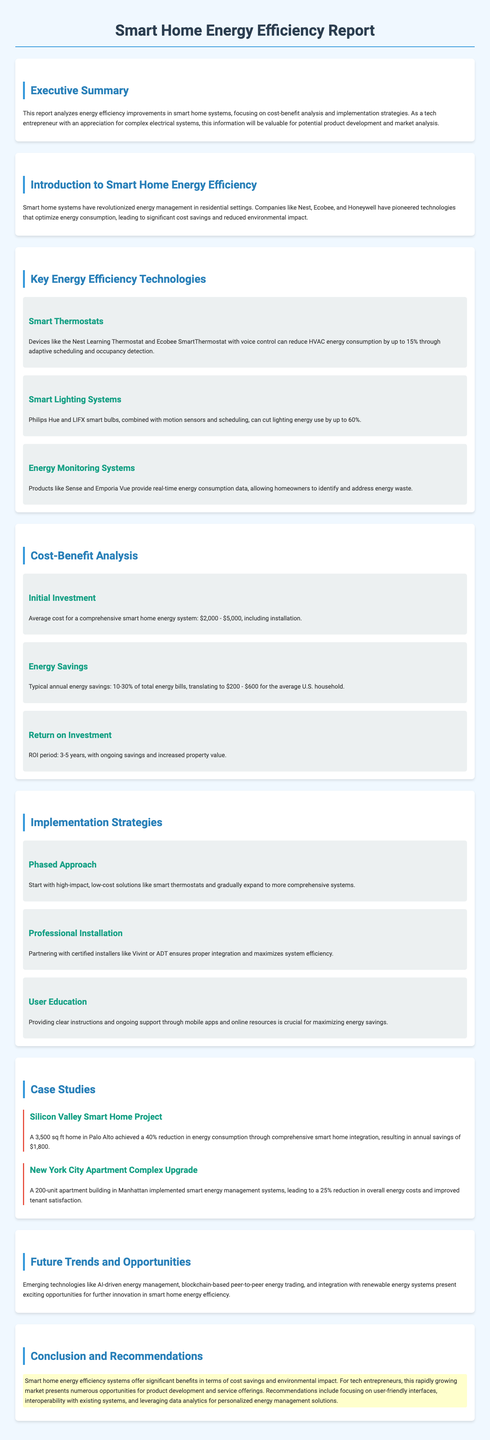What is the average cost for a comprehensive smart home energy system? The average cost is mentioned in the document as being between $2,000 and $5,000, including installation.
Answer: $2,000 - $5,000 What percentage can smart thermostats reduce HVAC energy consumption? The document states that smart thermostats can reduce HVAC energy consumption by up to 15%.
Answer: 15% What is the typical annual savings for an average U.S. household? The document indicates that typical annual energy savings translate to $200 to $600 for the average U.S. household.
Answer: $200 - $600 What strategy should be prioritized when implementing smart home systems? The report suggests starting with high-impact, low-cost solutions like smart thermostats as part of a phased approach.
Answer: Phased Approach What is the return on investment period for implementing smart home energy efficiency improvements? According to the report, the ROI period is between 3 to 5 years.
Answer: 3-5 years Which smart lighting system is mentioned as capable of cutting lighting energy use by up to 60%? The document specifically mentions Philips Hue and LIFX smart bulbs in this context.
Answer: Philips Hue and LIFX How much energy consumption reduction did the Silicon Valley smart home project achieve? The report states that the Silicon Valley Smart Home Project achieved a 40% reduction in energy consumption.
Answer: 40% What emerging technologies present opportunities for further innovation? The document highlights AI-driven energy management, blockchain-based peer-to-peer energy trading, and integration with renewable energy systems.
Answer: AI-driven energy management, blockchain-based peer-to-peer energy trading, integration with renewable energy systems What key detail is emphasized regarding user education in implementation strategies? The report underscores the importance of providing clear instructions and ongoing support through mobile apps and online resources for maximizing energy savings.
Answer: User Education 